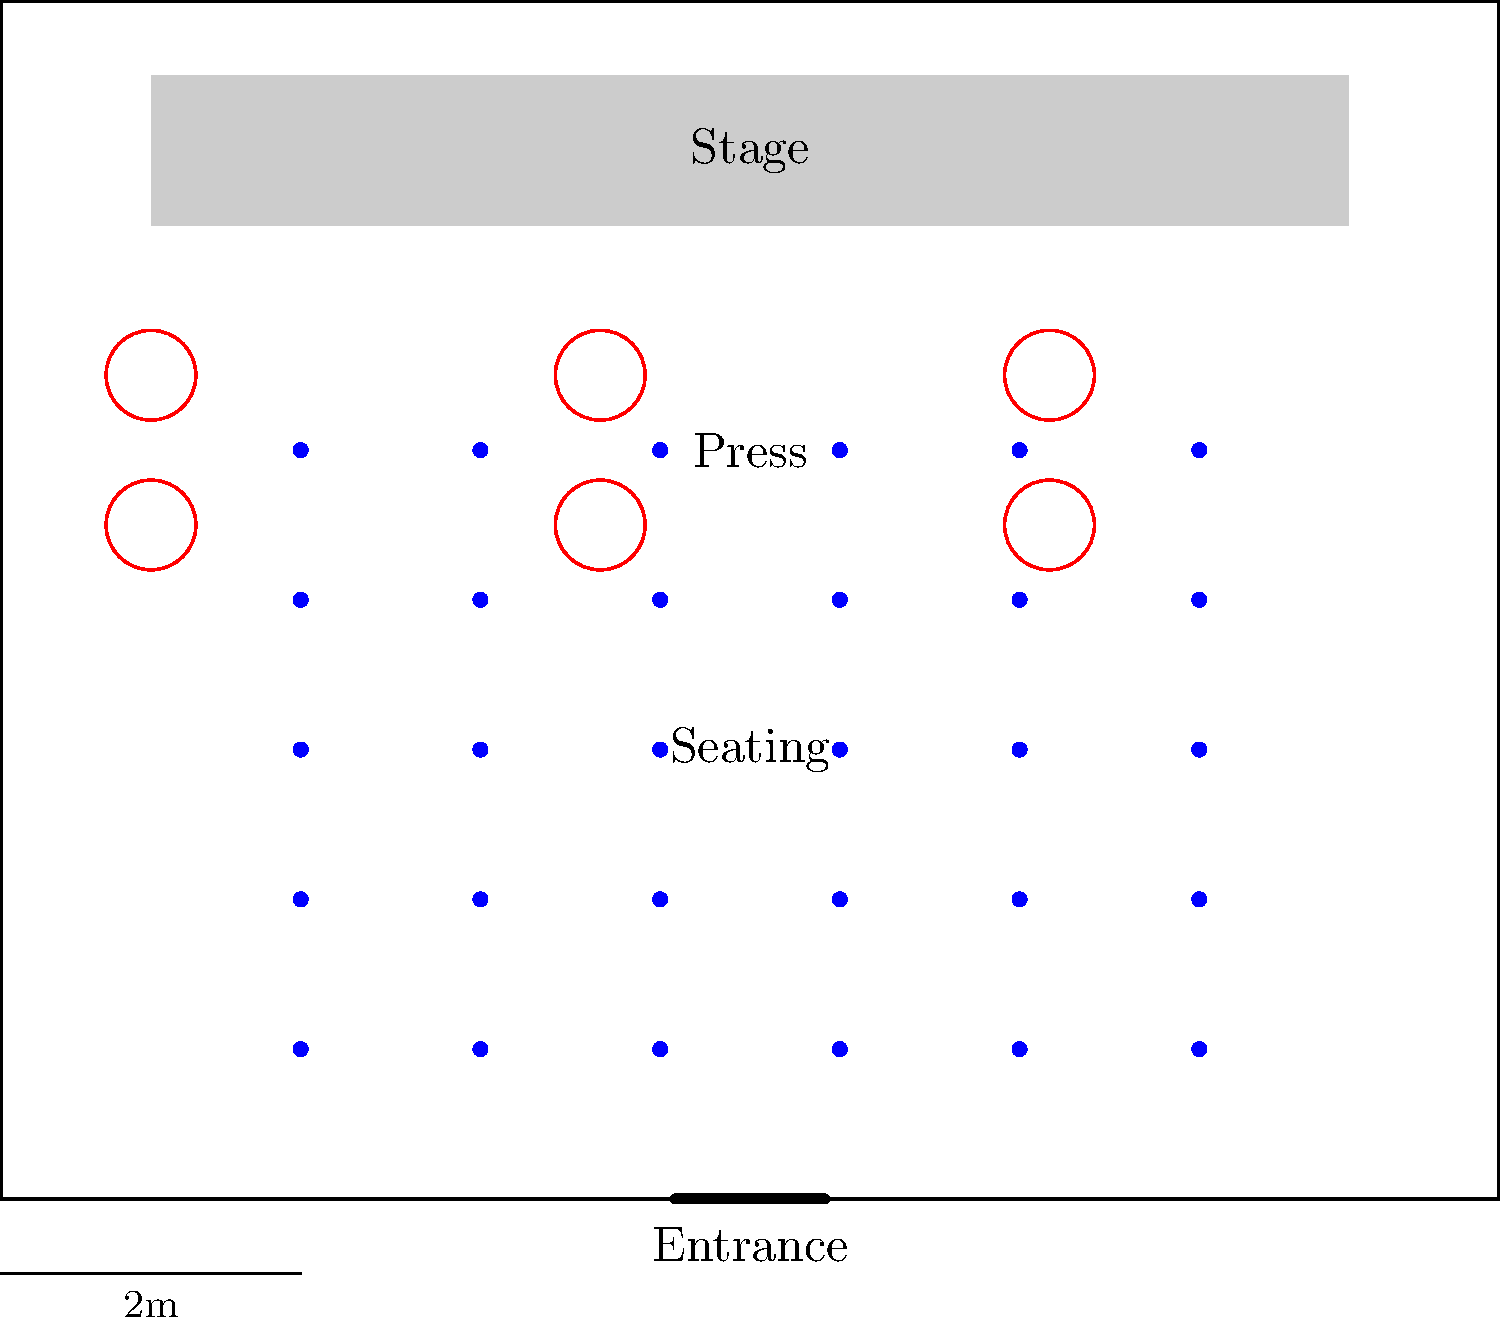As a PR specialist organizing a press conference, you're given the floor plan above for a conference room. The room dimensions are 10m x 8m. Given that you need to maximize media coverage while ensuring comfort for attendees, what is the maximum number of press representatives that can be accommodated in the designated press area without overcrowding? To determine the maximum number of press representatives that can be accommodated, we need to follow these steps:

1. Identify the press area: The press area is shown in the diagram with red circles, located between the seating area and the stage.

2. Count the number of press positions: The diagram shows 2 rows of 3 circles each, totaling 6 positions for press representatives.

3. Consider space requirements: Each circle represents a position for a press representative with their equipment (e.g., cameras, tripods). The spacing between the circles appears adequate for comfortable movement and setup.

4. Evaluate overcrowding: Given the layout, 6 press representatives would be the maximum number that can be accommodated without overcrowding. Adding more would likely interfere with the seating area or obstruct the view of the stage.

5. Consider the room size: The room is 10m x 8m, which is relatively compact. The current layout efficiently uses the available space while maintaining clear areas for different functions (seating, press, stage).

6. Factor in PR objectives: As a PR specialist, maximizing media coverage is crucial. The current layout allows for a good number of press representatives while still maintaining a professional and organized appearance.

Therefore, based on the given floor plan and PR considerations, the maximum number of press representatives that can be accommodated without overcrowding is 6.
Answer: 6 press representatives 